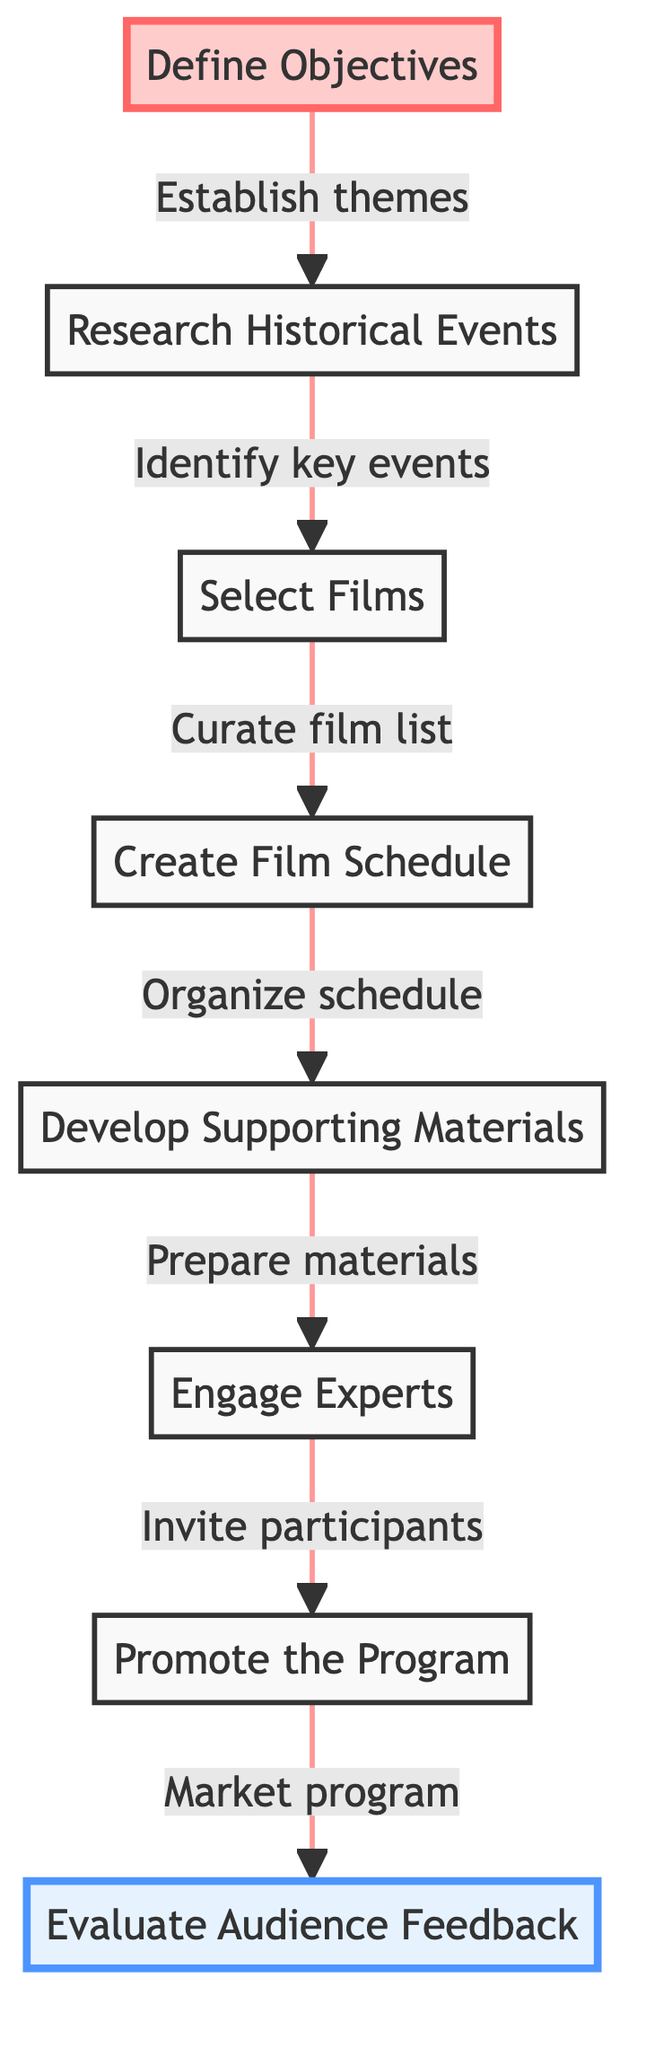What is the first step in the process? The first step is labeled "Define Objectives," which indicates that establishing themes is essential at the beginning of the curation process.
Answer: Define Objectives How many steps are there in total? There are eight steps total, starting from "Define Objectives" and ending with "Evaluate Audience Feedback." Each step is clearly numbered in a linear progression.
Answer: 8 What does the "Select Films" step lead to? "Select Films" leads to "Create Film Schedule," indicating that once films are selected, the next action is to organize them into a schedule.
Answer: Create Film Schedule Which step involves inviting historians or filmmakers? The step labeled "Engage Experts" involves inviting historians or filmmakers for discussions or Q&A sessions. It directly follows the "Develop Supporting Materials" step.
Answer: Engage Experts What is the last step in the curation process? The last step is "Evaluate Audience Feedback," which comes after "Promote the Program," indicating that post-program evaluation is the final action.
Answer: Evaluate Audience Feedback What relationship exists between "Research Historical Events" and "Select Films"? The relationship is that "Research Historical Events" is a prerequisite for "Select Films," as identifying key events is necessary to curate an appropriate film list.
Answer: Identify key events What type of materials are developed in the process? The materials developed are "discussion guides, background readings, and contextual information," which provide context to enhance the audience's understanding.
Answer: Supporting Materials In what phase does marketing the program occur? Marketing occurs in the "Promote the Program" phase, which is after films are scheduled and materials are developed. This phase includes using social media and local organizations for outreach.
Answer: Promote the Program 